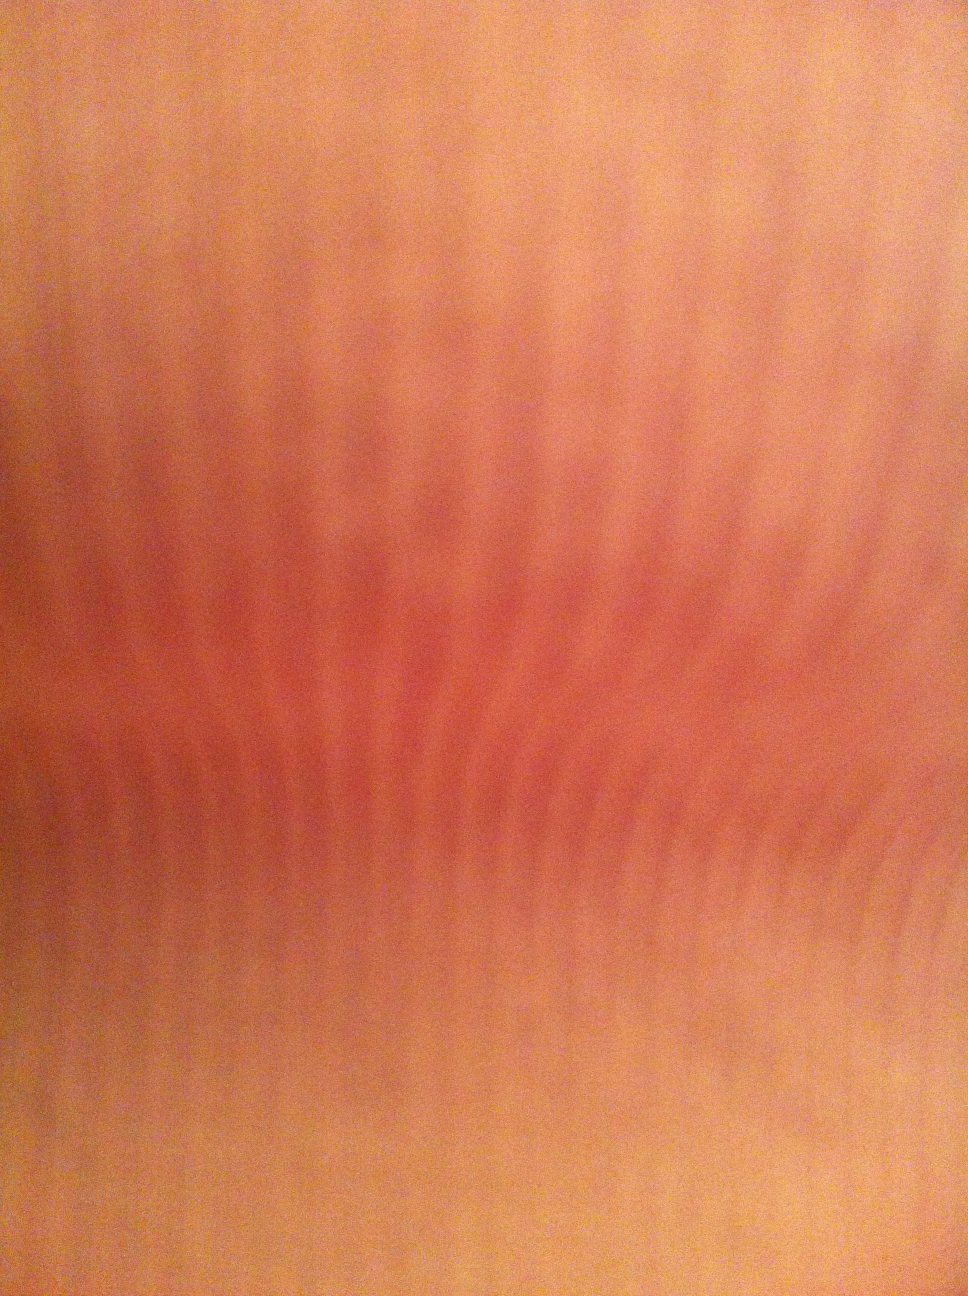Is there a specific texture or pattern that can be seen in this image? The image seems to display a soft, somewhat consistent texture which resembles that of human skin. The faint parallel lines could be indicative of natural skin lines or wrinkles. 